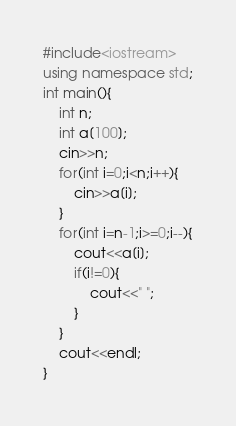Convert code to text. <code><loc_0><loc_0><loc_500><loc_500><_C++_>#include<iostream>
using namespace std;
int main(){
	int n;
	int a[100];
	cin>>n;
	for(int i=0;i<n;i++){
		cin>>a[i];
	}
	for(int i=n-1;i>=0;i--){
		cout<<a[i];
		if(i!=0){
			cout<<" ";
		}
	}
	cout<<endl;
}</code> 